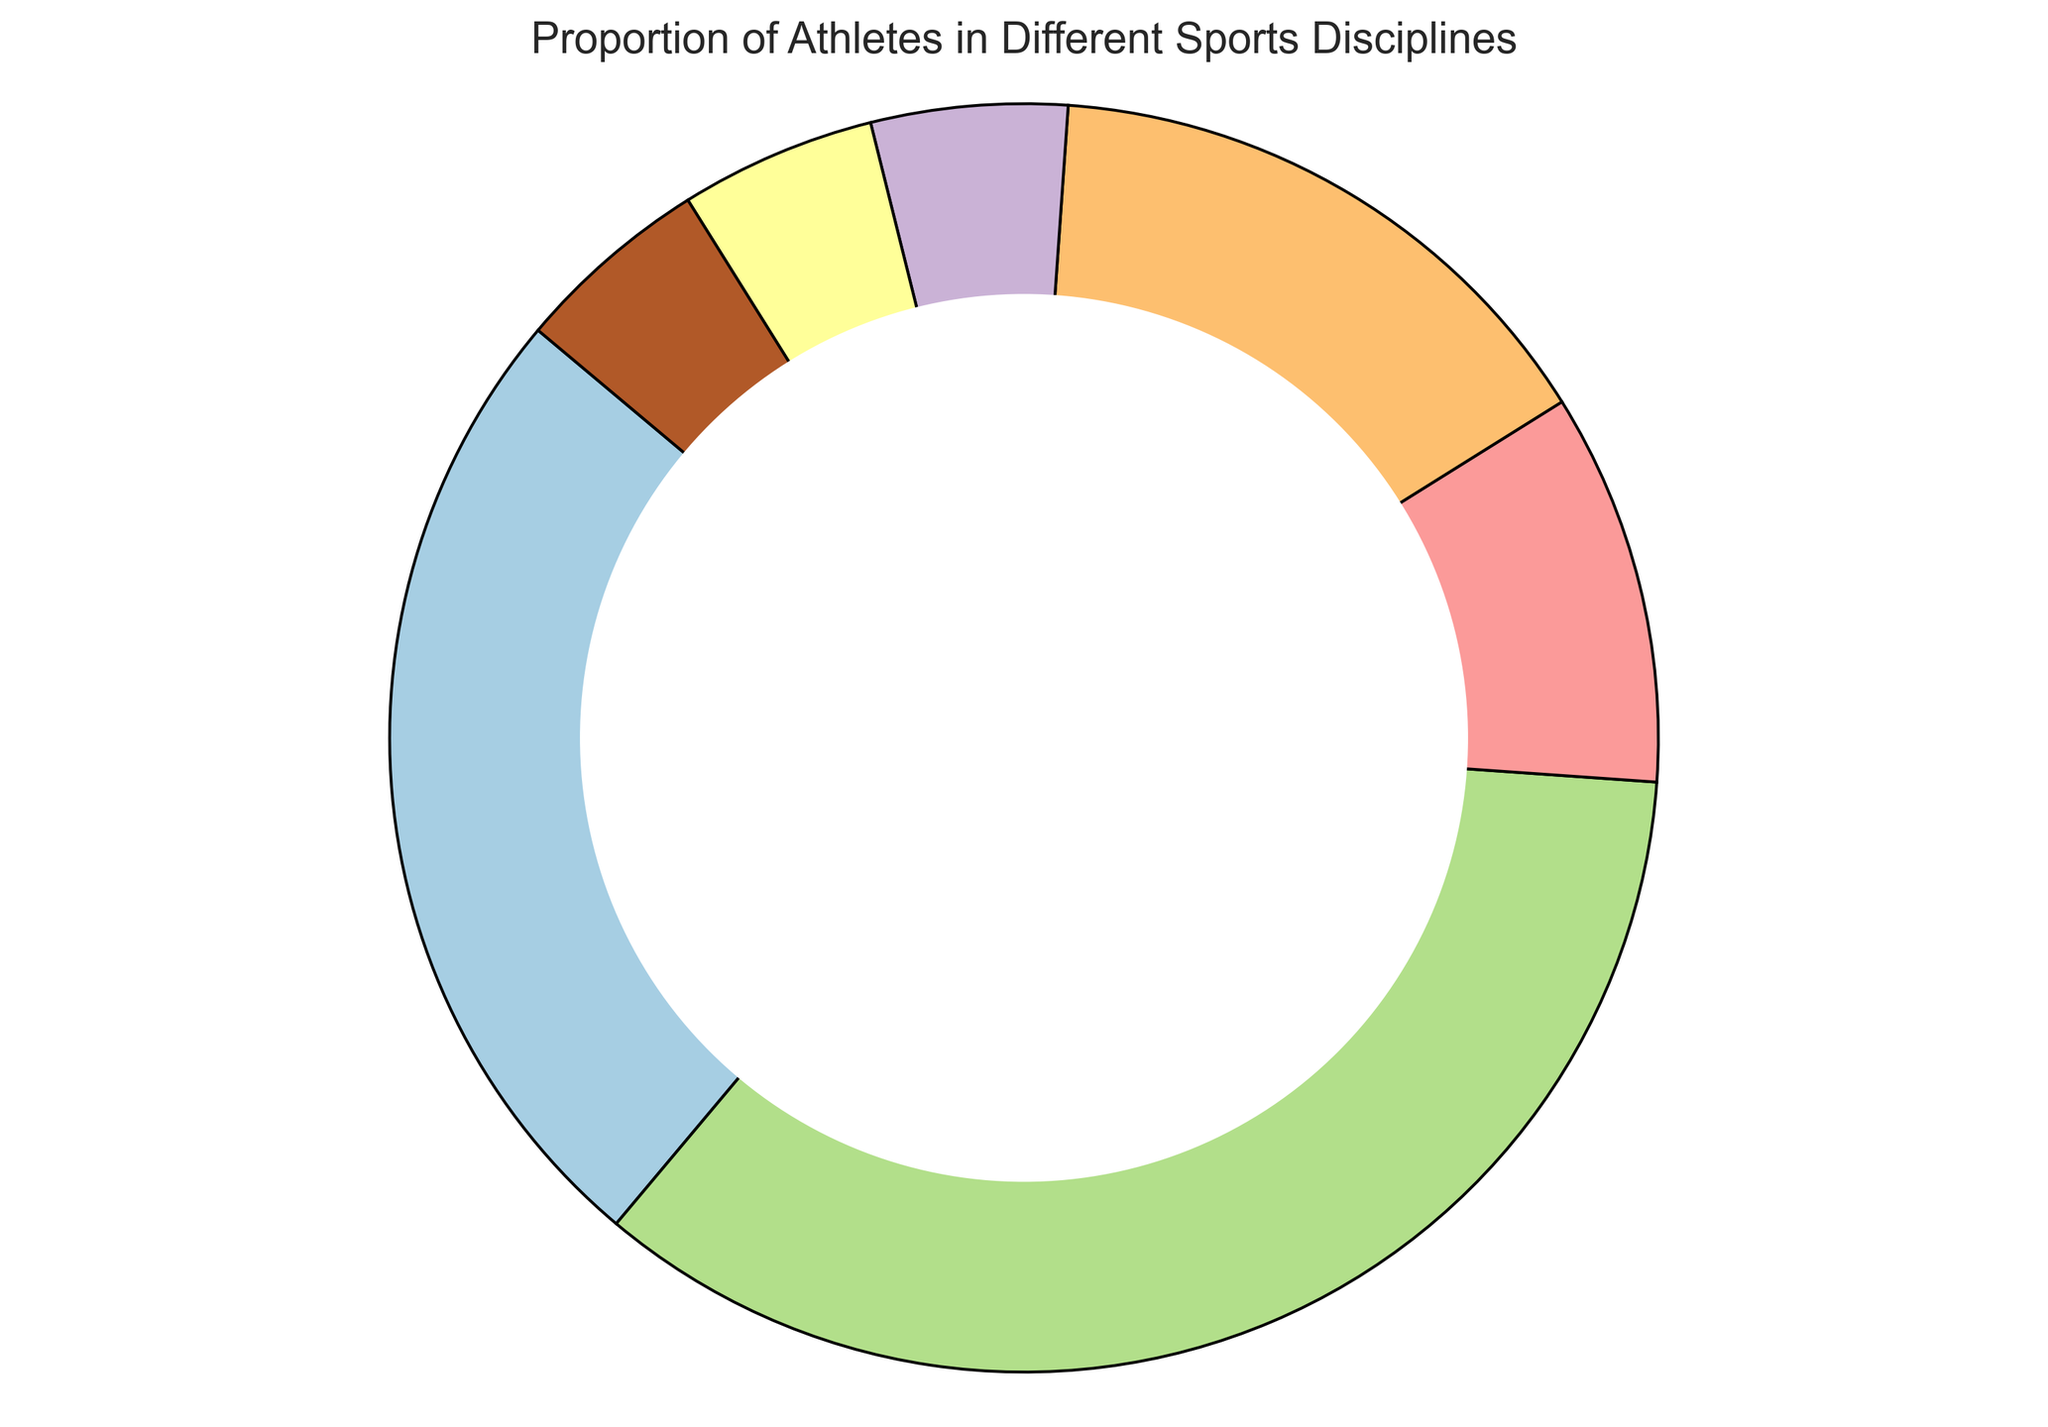What sport has the largest proportion of athletes? The largest segment in the pie chart represents the sport with the largest proportion. In this chart, the largest segment is labeled as "Soccer."
Answer: Soccer Which sports have a proportion of 5%? There are three segments in the pie chart that each have a 5% proportion. These segments are labeled "Swimming," "Track_and_Field," and "Other."
Answer: Swimming, Track_and_Field, Other What is the combined proportion of athletes in Soccer and Basketball? To find the combined proportion of athletes in Soccer and Basketball, add their individual proportions: 35% (Soccer) + 25% (Basketball) = 60%.
Answer: 60% How much larger is the proportion of Soccer compared to Tennis? The proportion of Soccer is 35% and the proportion of Tennis is 10%. Subtract the proportion of Tennis from that of Soccer to find the difference: 35% - 10% = 25%.
Answer: 25% What proportion of athletes are involved in either Baseball or Tennis? Add the proportion of athletes in Baseball (15%) to that in Tennis (10%): 15% + 10% = 25%.
Answer: 25% Which sport has a larger proportion of athletes: Baseball or Tennis? By comparing the segments in the pie chart, the Baseball segment has a 15% proportion, while the Tennis segment has a 10% proportion. Therefore, Baseball has a larger proportion.
Answer: Baseball Is the combined proportion of athletes in Track_and_Field, Swimming, and Other larger or smaller than the proportion of Basketball athletes? Combined proportion of Track_and_Field (5%), Swimming (5%), and Other (5%) is 5% + 5% + 5% = 15%. The proportion of Basketball athletes is 25%, which is larger.
Answer: Smaller What is the difference in proportions between the sport with the largest and smallest representation? The largest representation is Soccer with 35% and the smallest representation segments are Swimming, Track_and_Field, and Other, each with 5%. The difference is 35% (Soccer) - 5% (smallest) = 30%.
Answer: 30% If the proportion of Tennis athletes doubled, what would it be and where would it rank compared to other sports? Doubling the proportion of Tennis athletes: 10% * 2 = 20%. Ranking this against other sports: Soccer (35%), Basketball (25%), Baseball (15%), Tennis (20% - new), it would be third, after Soccer and Basketball.
Answer: 20%, third 